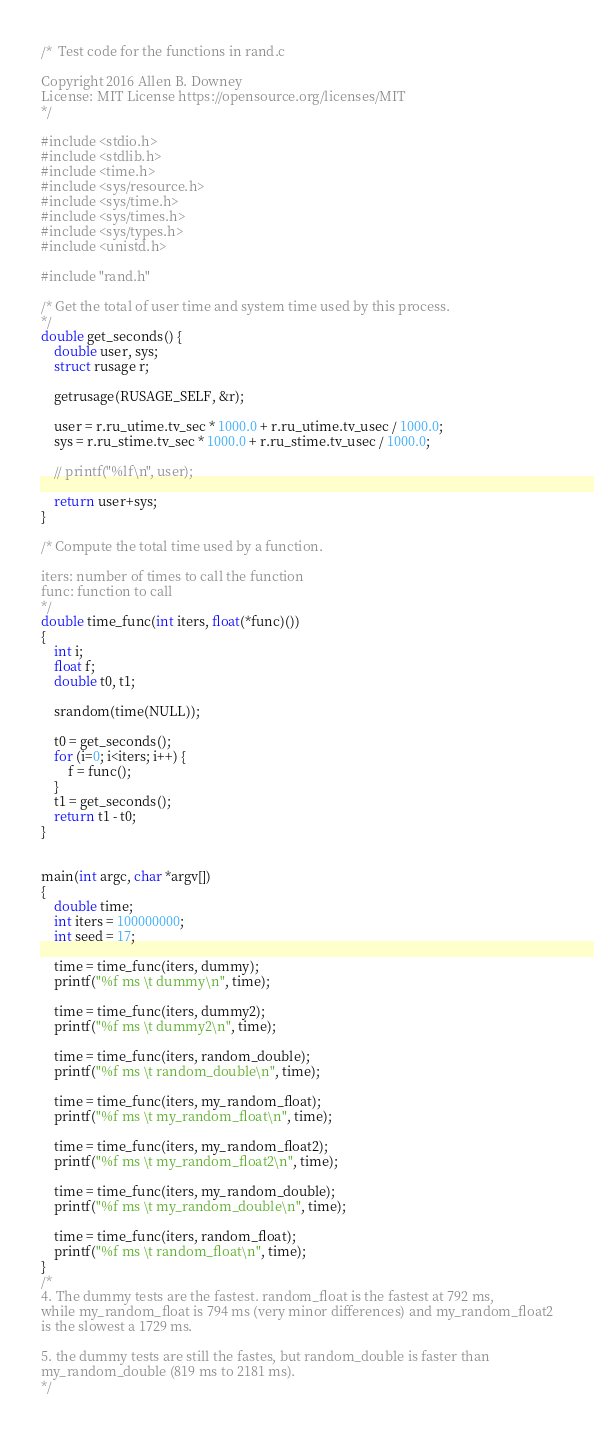Convert code to text. <code><loc_0><loc_0><loc_500><loc_500><_C_>/*  Test code for the functions in rand.c

Copyright 2016 Allen B. Downey
License: MIT License https://opensource.org/licenses/MIT
*/

#include <stdio.h>
#include <stdlib.h>
#include <time.h>
#include <sys/resource.h>
#include <sys/time.h>
#include <sys/times.h>
#include <sys/types.h>
#include <unistd.h>

#include "rand.h"

/* Get the total of user time and system time used by this process.
*/
double get_seconds() {
    double user, sys;
    struct rusage r;

    getrusage(RUSAGE_SELF, &r);

    user = r.ru_utime.tv_sec * 1000.0 + r.ru_utime.tv_usec / 1000.0;
    sys = r.ru_stime.tv_sec * 1000.0 + r.ru_stime.tv_usec / 1000.0;

    // printf("%lf\n", user);

    return user+sys;
}

/* Compute the total time used by a function.

iters: number of times to call the function
func: function to call
*/
double time_func(int iters, float(*func)())
{
    int i;
    float f;
    double t0, t1;

    srandom(time(NULL));

    t0 = get_seconds();
    for (i=0; i<iters; i++) {
        f = func();
    }
    t1 = get_seconds();
    return t1 - t0;
}


main(int argc, char *argv[])
{
    double time;
    int iters = 100000000;
    int seed = 17;

    time = time_func(iters, dummy);
    printf("%f ms \t dummy\n", time);

    time = time_func(iters, dummy2);
    printf("%f ms \t dummy2\n", time);

    time = time_func(iters, random_double);
    printf("%f ms \t random_double\n", time);

    time = time_func(iters, my_random_float);
    printf("%f ms \t my_random_float\n", time);

    time = time_func(iters, my_random_float2);
    printf("%f ms \t my_random_float2\n", time);

    time = time_func(iters, my_random_double);
    printf("%f ms \t my_random_double\n", time);

    time = time_func(iters, random_float);
    printf("%f ms \t random_float\n", time);
}
/*
4. The dummy tests are the fastest. random_float is the fastest at 792 ms,
while my_random_float is 794 ms (very minor differences) and my_random_float2
is the slowest a 1729 ms.

5. the dummy tests are still the fastes, but random_double is faster than
my_random_double (819 ms to 2181 ms). 
*/
</code> 